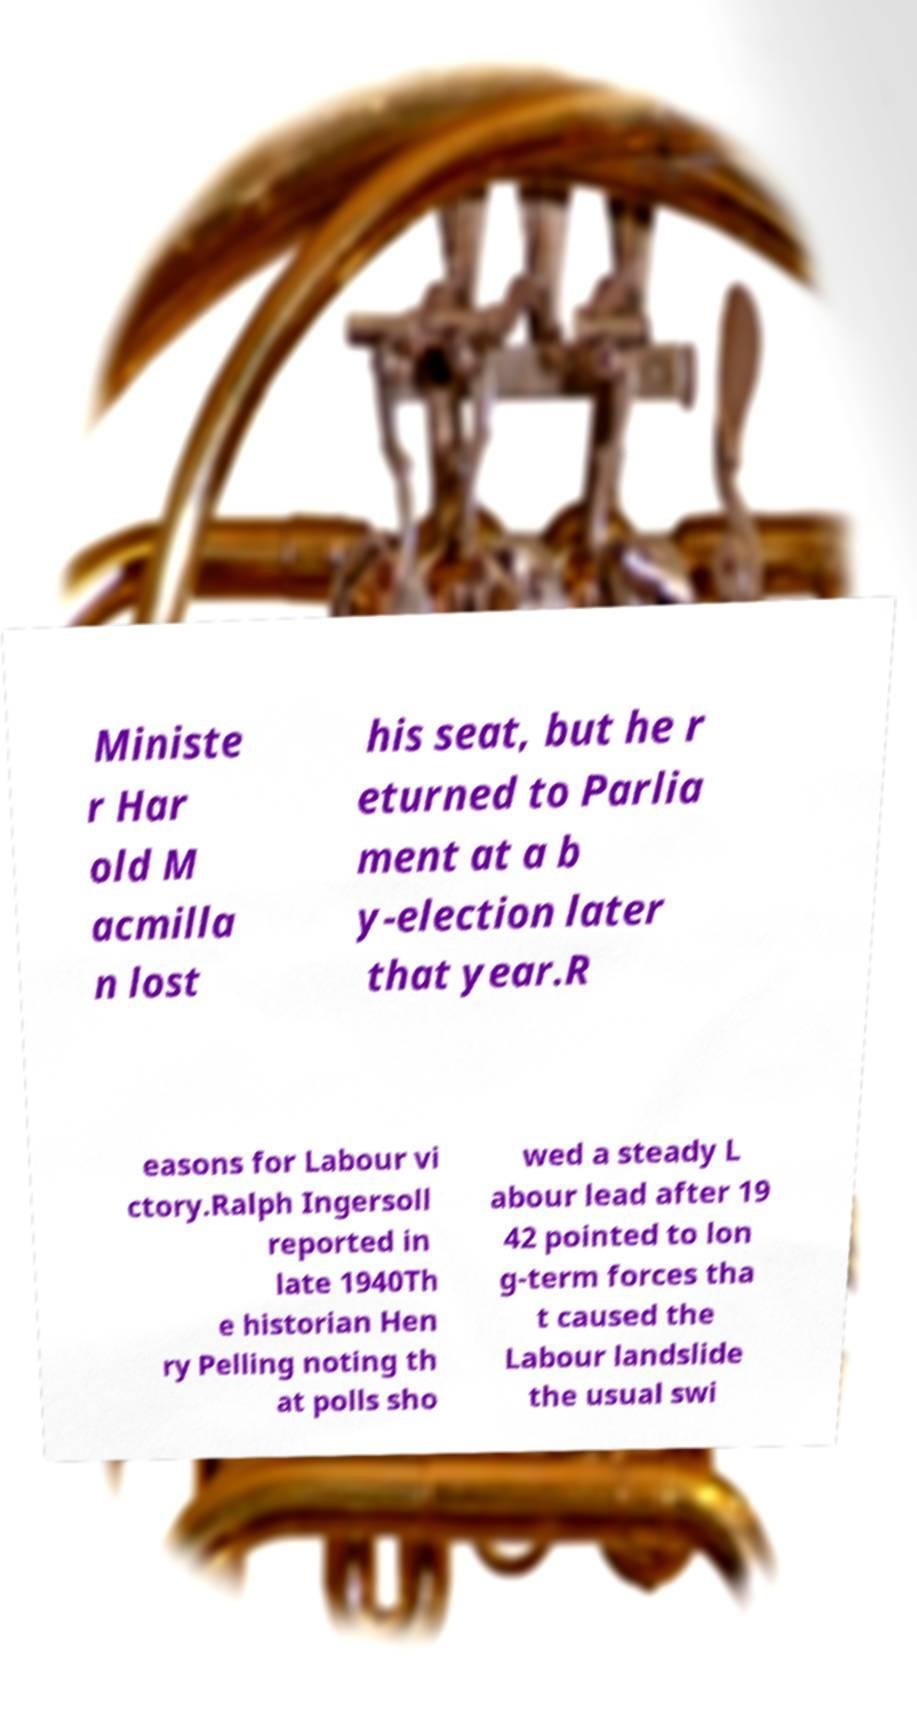I need the written content from this picture converted into text. Can you do that? Ministe r Har old M acmilla n lost his seat, but he r eturned to Parlia ment at a b y-election later that year.R easons for Labour vi ctory.Ralph Ingersoll reported in late 1940Th e historian Hen ry Pelling noting th at polls sho wed a steady L abour lead after 19 42 pointed to lon g-term forces tha t caused the Labour landslide the usual swi 